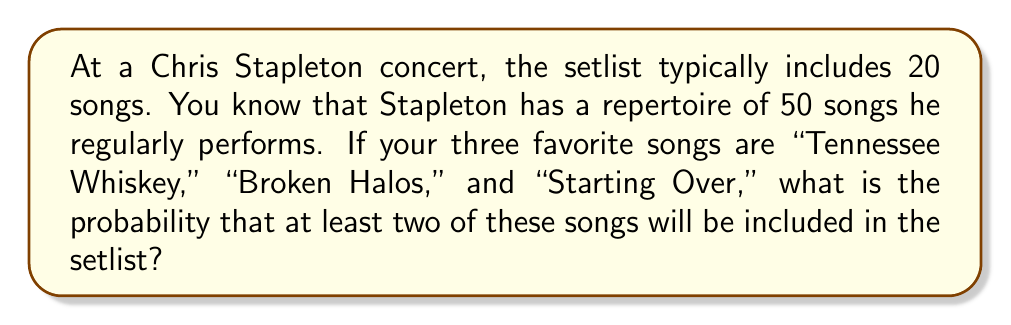What is the answer to this math problem? Let's approach this step-by-step using combinatorial probability:

1) First, we need to calculate the total number of possible 20-song setlists from 50 songs:
   $${50 \choose 20}$$

2) Now, we need to calculate the number of setlists that include at least two of the three favorite songs. We can do this by subtracting the number of setlists with one or none of the favorite songs from the total number of setlists:

   $$P(\text{at least 2}) = 1 - P(\text{0 or 1})$$

3) To calculate $P(\text{0 or 1})$:
   
   a) Number of setlists with none of the favorites:
      $${47 \choose 20}$$
   
   b) Number of setlists with exactly one favorite:
      $$3 \cdot {47 \choose 19}$$

4) Therefore, the probability is:

   $$P(\text{at least 2}) = 1 - \frac{{47 \choose 20} + 3 \cdot {47 \choose 19}}{{50 \choose 20}}$$

5) Calculating this:
   $${50 \choose 20} = 47,129,212,243,960$$
   $${47 \choose 20} = 31,469,396,248,000$$
   $${47 \choose 19} = 15,734,698,124,000$$

   $$P(\text{at least 2}) = 1 - \frac{31,469,396,248,000 + 3 \cdot 15,734,698,124,000}{47,129,212,243,960}$$
   $$= 1 - \frac{78,673,490,620,000}{47,129,212,243,960}$$
   $$\approx 0.3307$$
Answer: $\approx 0.3307$ or about $33.07\%$ 